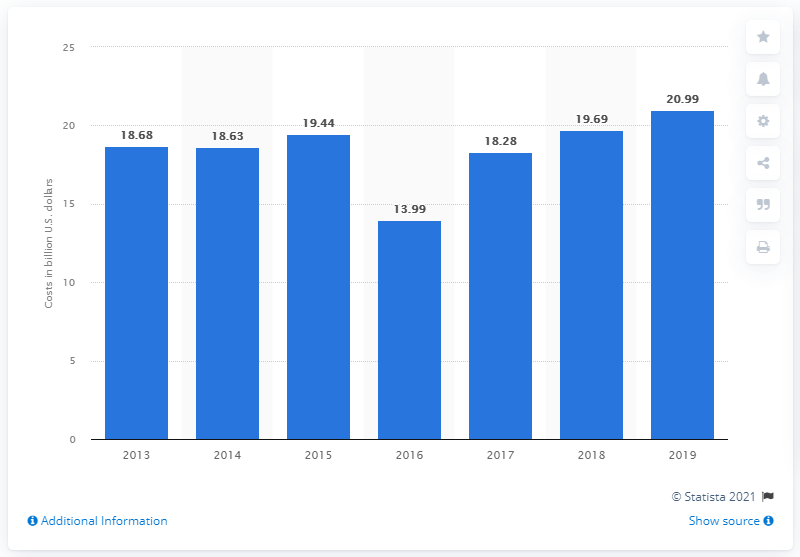Mention a couple of crucial points in this snapshot. According to data collected in 2019, the defense costs and containment expenses of U.S. insurers amounted to 20.99. 